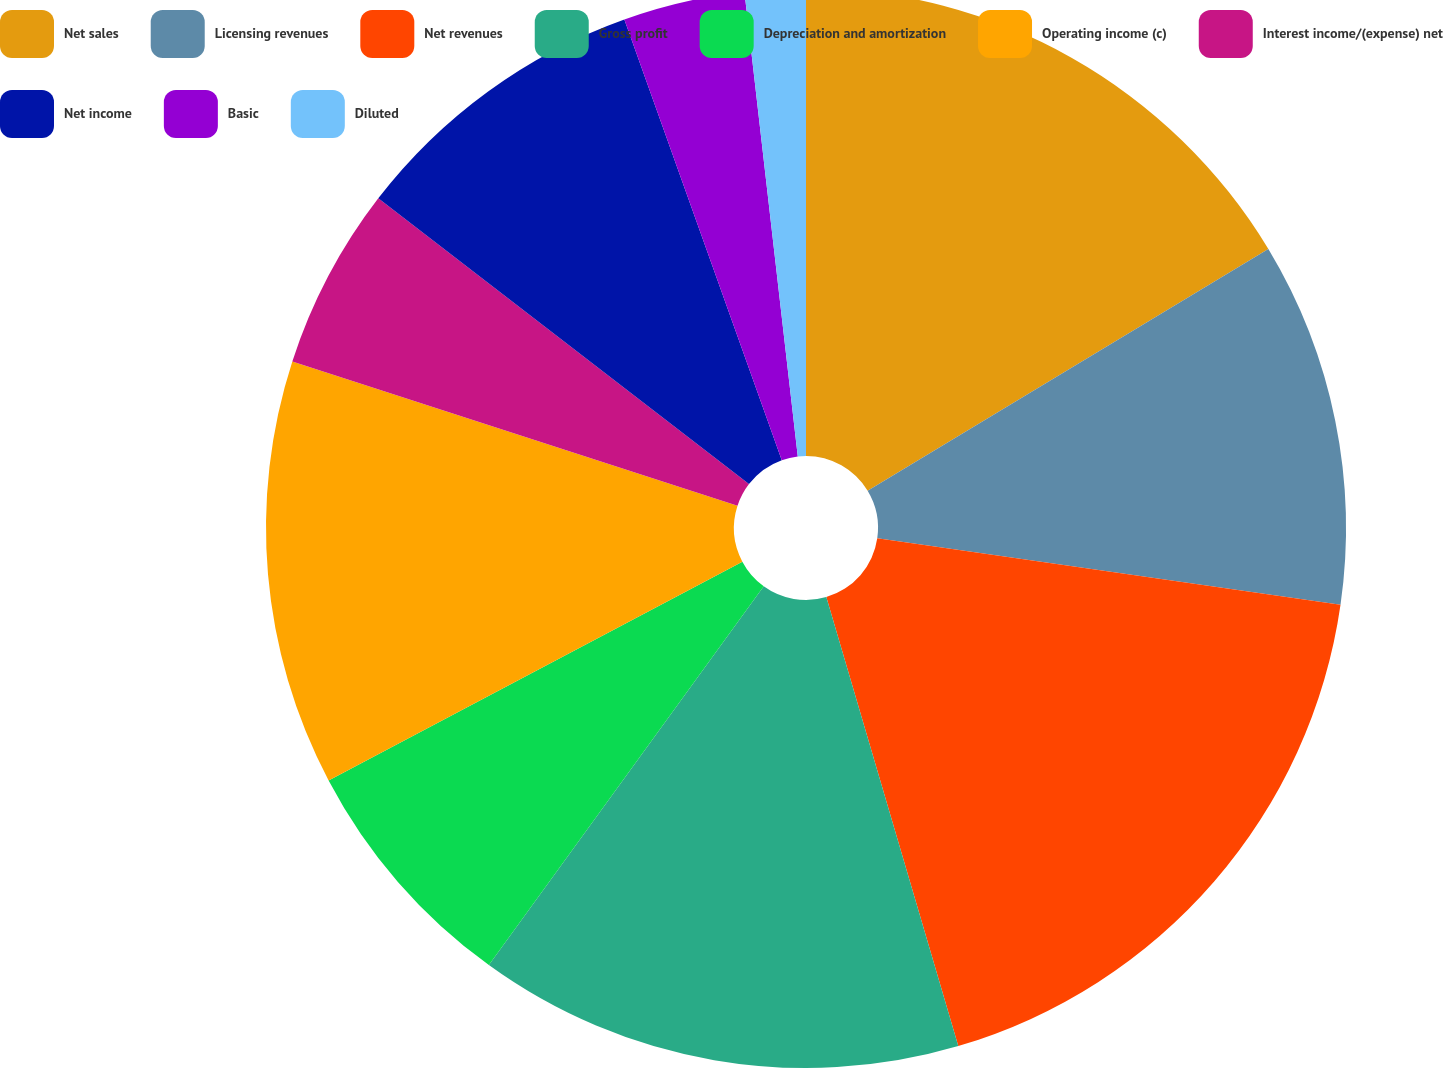<chart> <loc_0><loc_0><loc_500><loc_500><pie_chart><fcel>Net sales<fcel>Licensing revenues<fcel>Net revenues<fcel>Gross profit<fcel>Depreciation and amortization<fcel>Operating income (c)<fcel>Interest income/(expense) net<fcel>Net income<fcel>Basic<fcel>Diluted<nl><fcel>16.36%<fcel>10.91%<fcel>18.18%<fcel>14.54%<fcel>7.27%<fcel>12.73%<fcel>5.46%<fcel>9.09%<fcel>3.64%<fcel>1.82%<nl></chart> 